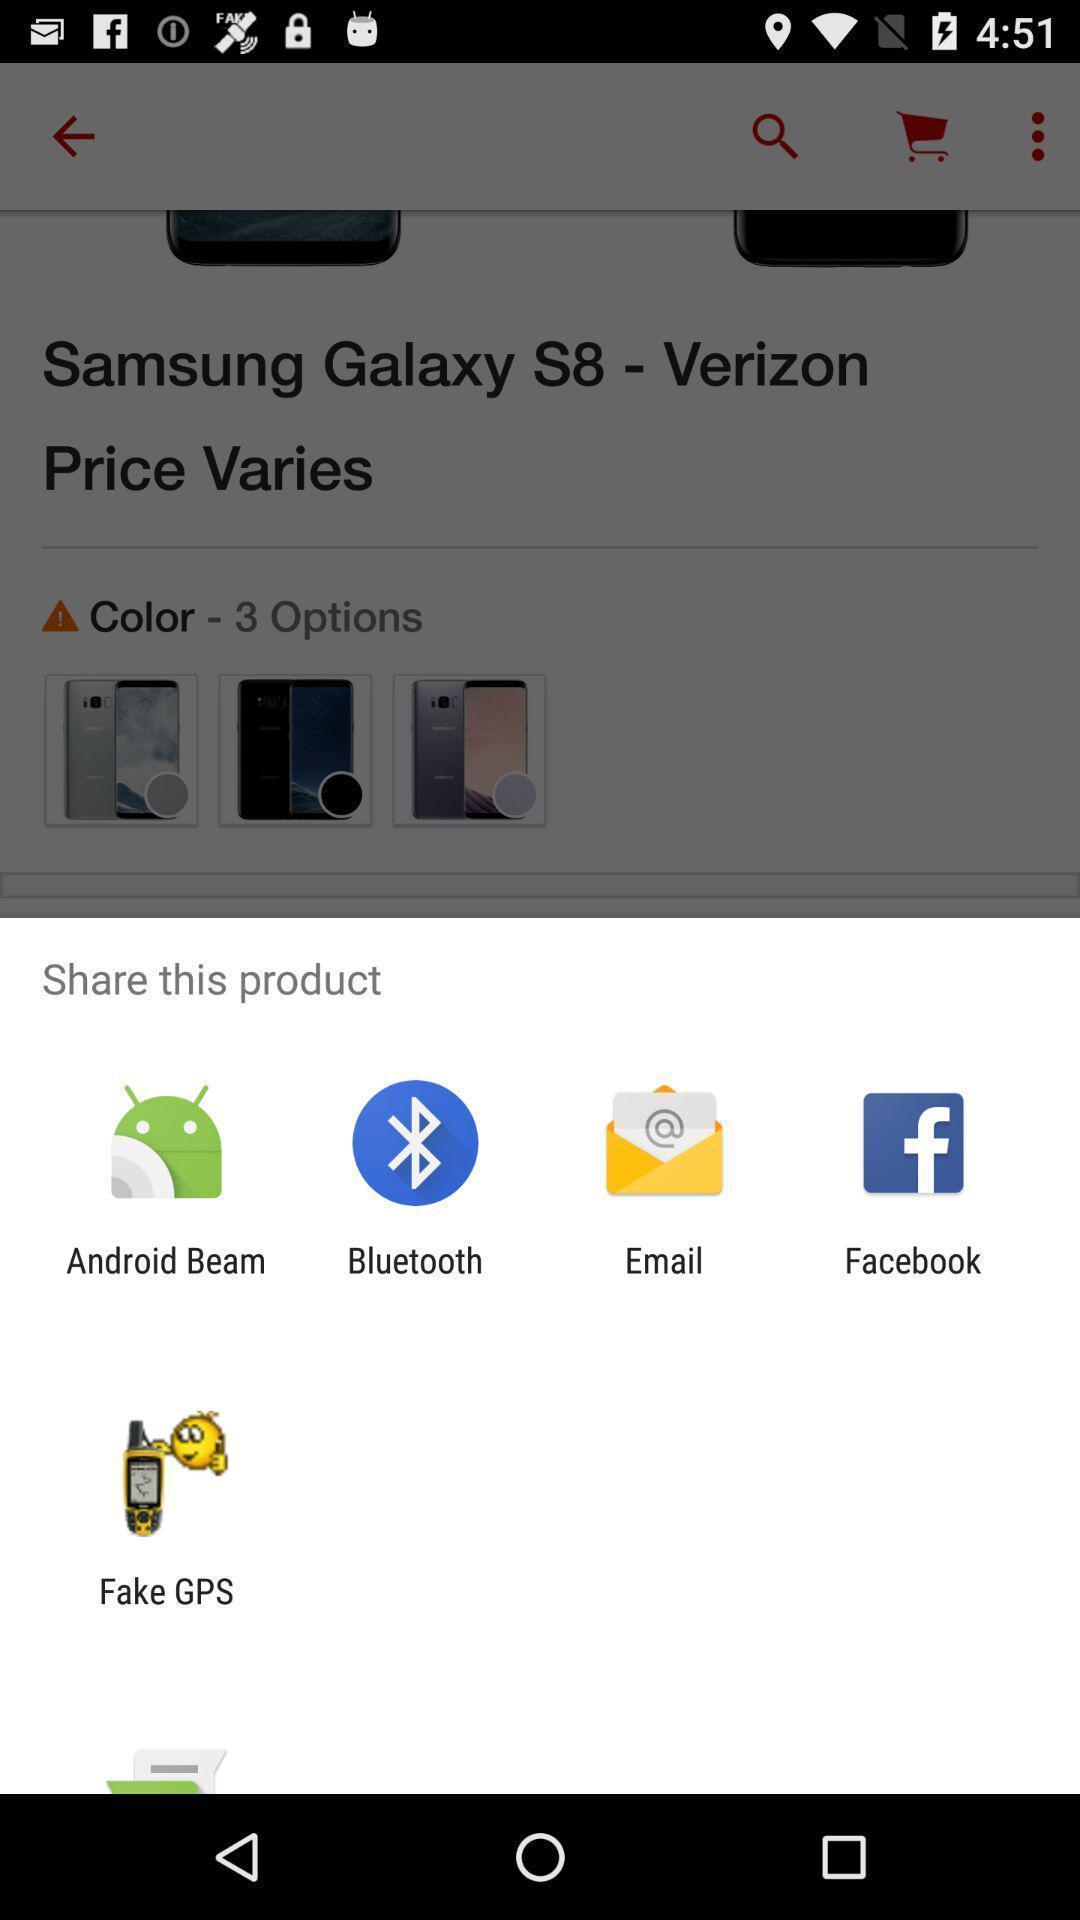What details can you identify in this image? Popup to share a product for the shopping app. 